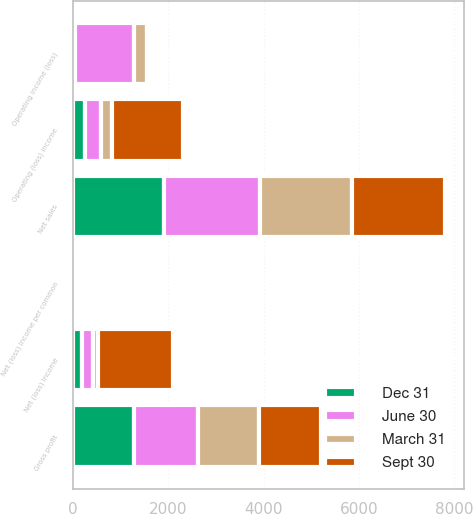Convert chart. <chart><loc_0><loc_0><loc_500><loc_500><stacked_bar_chart><ecel><fcel>Net sales<fcel>Gross profit<fcel>Operating (loss) income<fcel>Net (loss) income<fcel>Net (loss) income per common<fcel>Operating income (loss)<nl><fcel>Sept 30<fcel>1960<fcel>1297<fcel>1486<fcel>1589<fcel>1.05<fcel>11<nl><fcel>March 31<fcel>1928<fcel>1274<fcel>231<fcel>98<fcel>0.06<fcel>275<nl><fcel>Dec 31<fcel>1916<fcel>1293<fcel>251<fcel>190<fcel>0.12<fcel>51<nl><fcel>June 30<fcel>2002<fcel>1342<fcel>349<fcel>236<fcel>0.15<fcel>1231<nl></chart> 